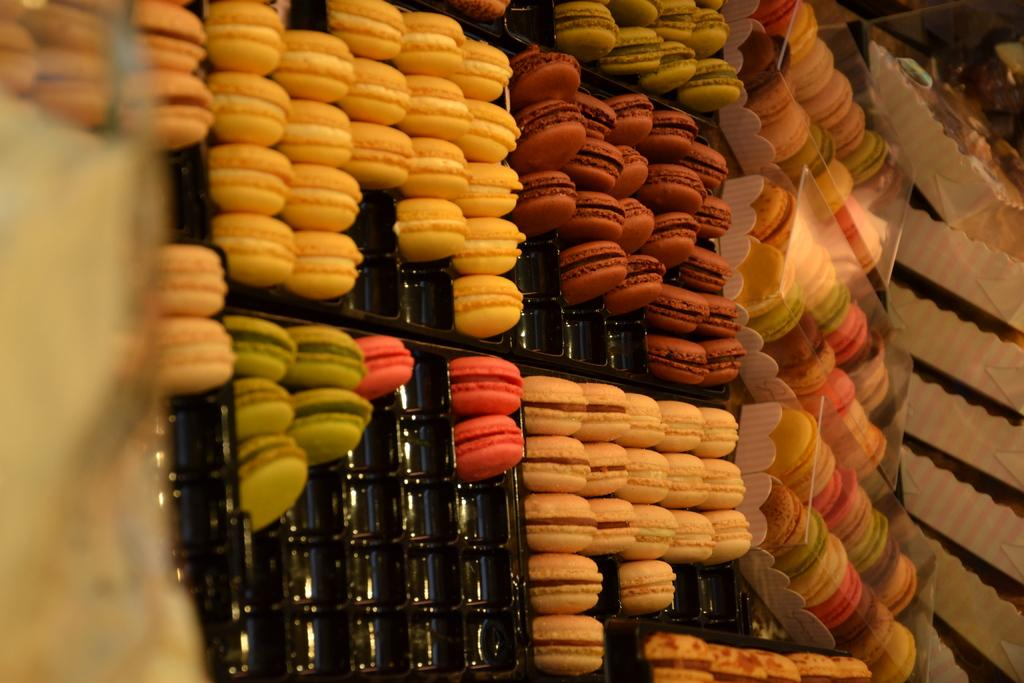What can be seen in the trays in the image? There are food items in trays in the image. What is located on the right side of the image? There are paper covers on the right side of the image. What type of machine can be seen operating in the wilderness in the image? There is no machine or wilderness present in the image; it only features food items in trays and paper covers. 